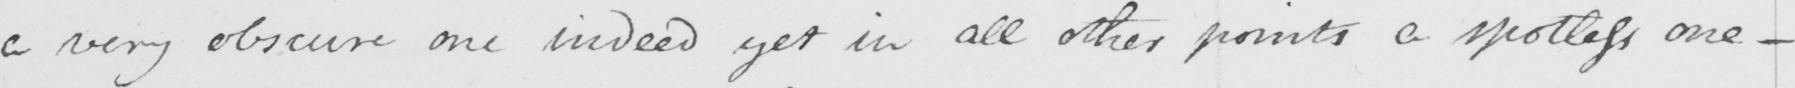Please provide the text content of this handwritten line. a very obscure one indeed yet in all other points a spotless one  _ 